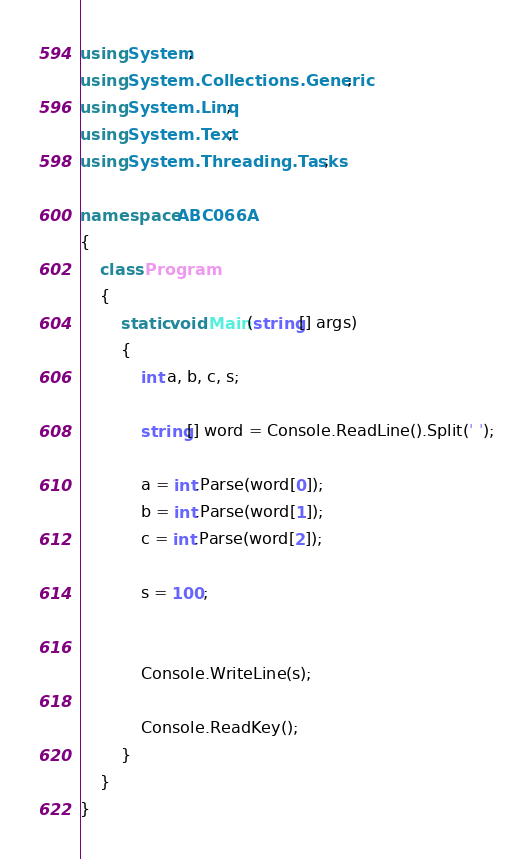<code> <loc_0><loc_0><loc_500><loc_500><_C#_>using System;
using System.Collections.Generic;
using System.Linq;
using System.Text;
using System.Threading.Tasks;

namespace ABC066A
{
    class Program
    {
        static void Main(string[] args)
        {
            int a, b, c, s;

            string[] word = Console.ReadLine().Split(' ');

            a = int.Parse(word[0]);
            b = int.Parse(word[1]);
            c = int.Parse(word[2]);

            s = 100;


            Console.WriteLine(s);

            Console.ReadKey();
        }
    }
}</code> 